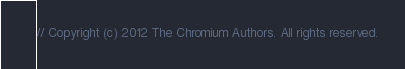Convert code to text. <code><loc_0><loc_0><loc_500><loc_500><_ObjectiveC_>// Copyright (c) 2012 The Chromium Authors. All rights reserved.</code> 